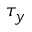<formula> <loc_0><loc_0><loc_500><loc_500>\tau _ { y }</formula> 